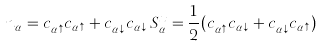Convert formula to latex. <formula><loc_0><loc_0><loc_500><loc_500>n _ { \alpha } = c _ { \alpha \uparrow } ^ { \dagger } c _ { \alpha \uparrow } + c _ { \alpha \downarrow } ^ { \dagger } c _ { \alpha \downarrow } \, S _ { \alpha } ^ { x } = \frac { 1 } { 2 } ( c _ { \alpha \uparrow } ^ { \dagger } c _ { \alpha \downarrow } + c _ { \alpha \downarrow } ^ { \dagger } c _ { \alpha \uparrow } )</formula> 